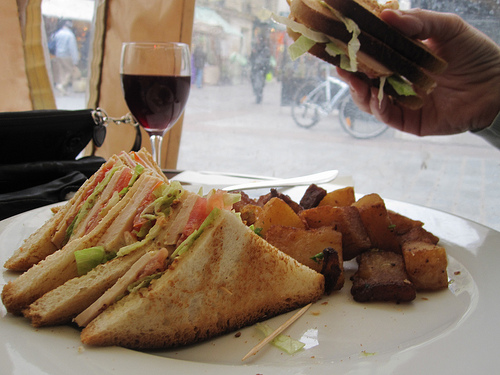<image>
Is there a wine behind the sandwich? Yes. From this viewpoint, the wine is positioned behind the sandwich, with the sandwich partially or fully occluding the wine. 